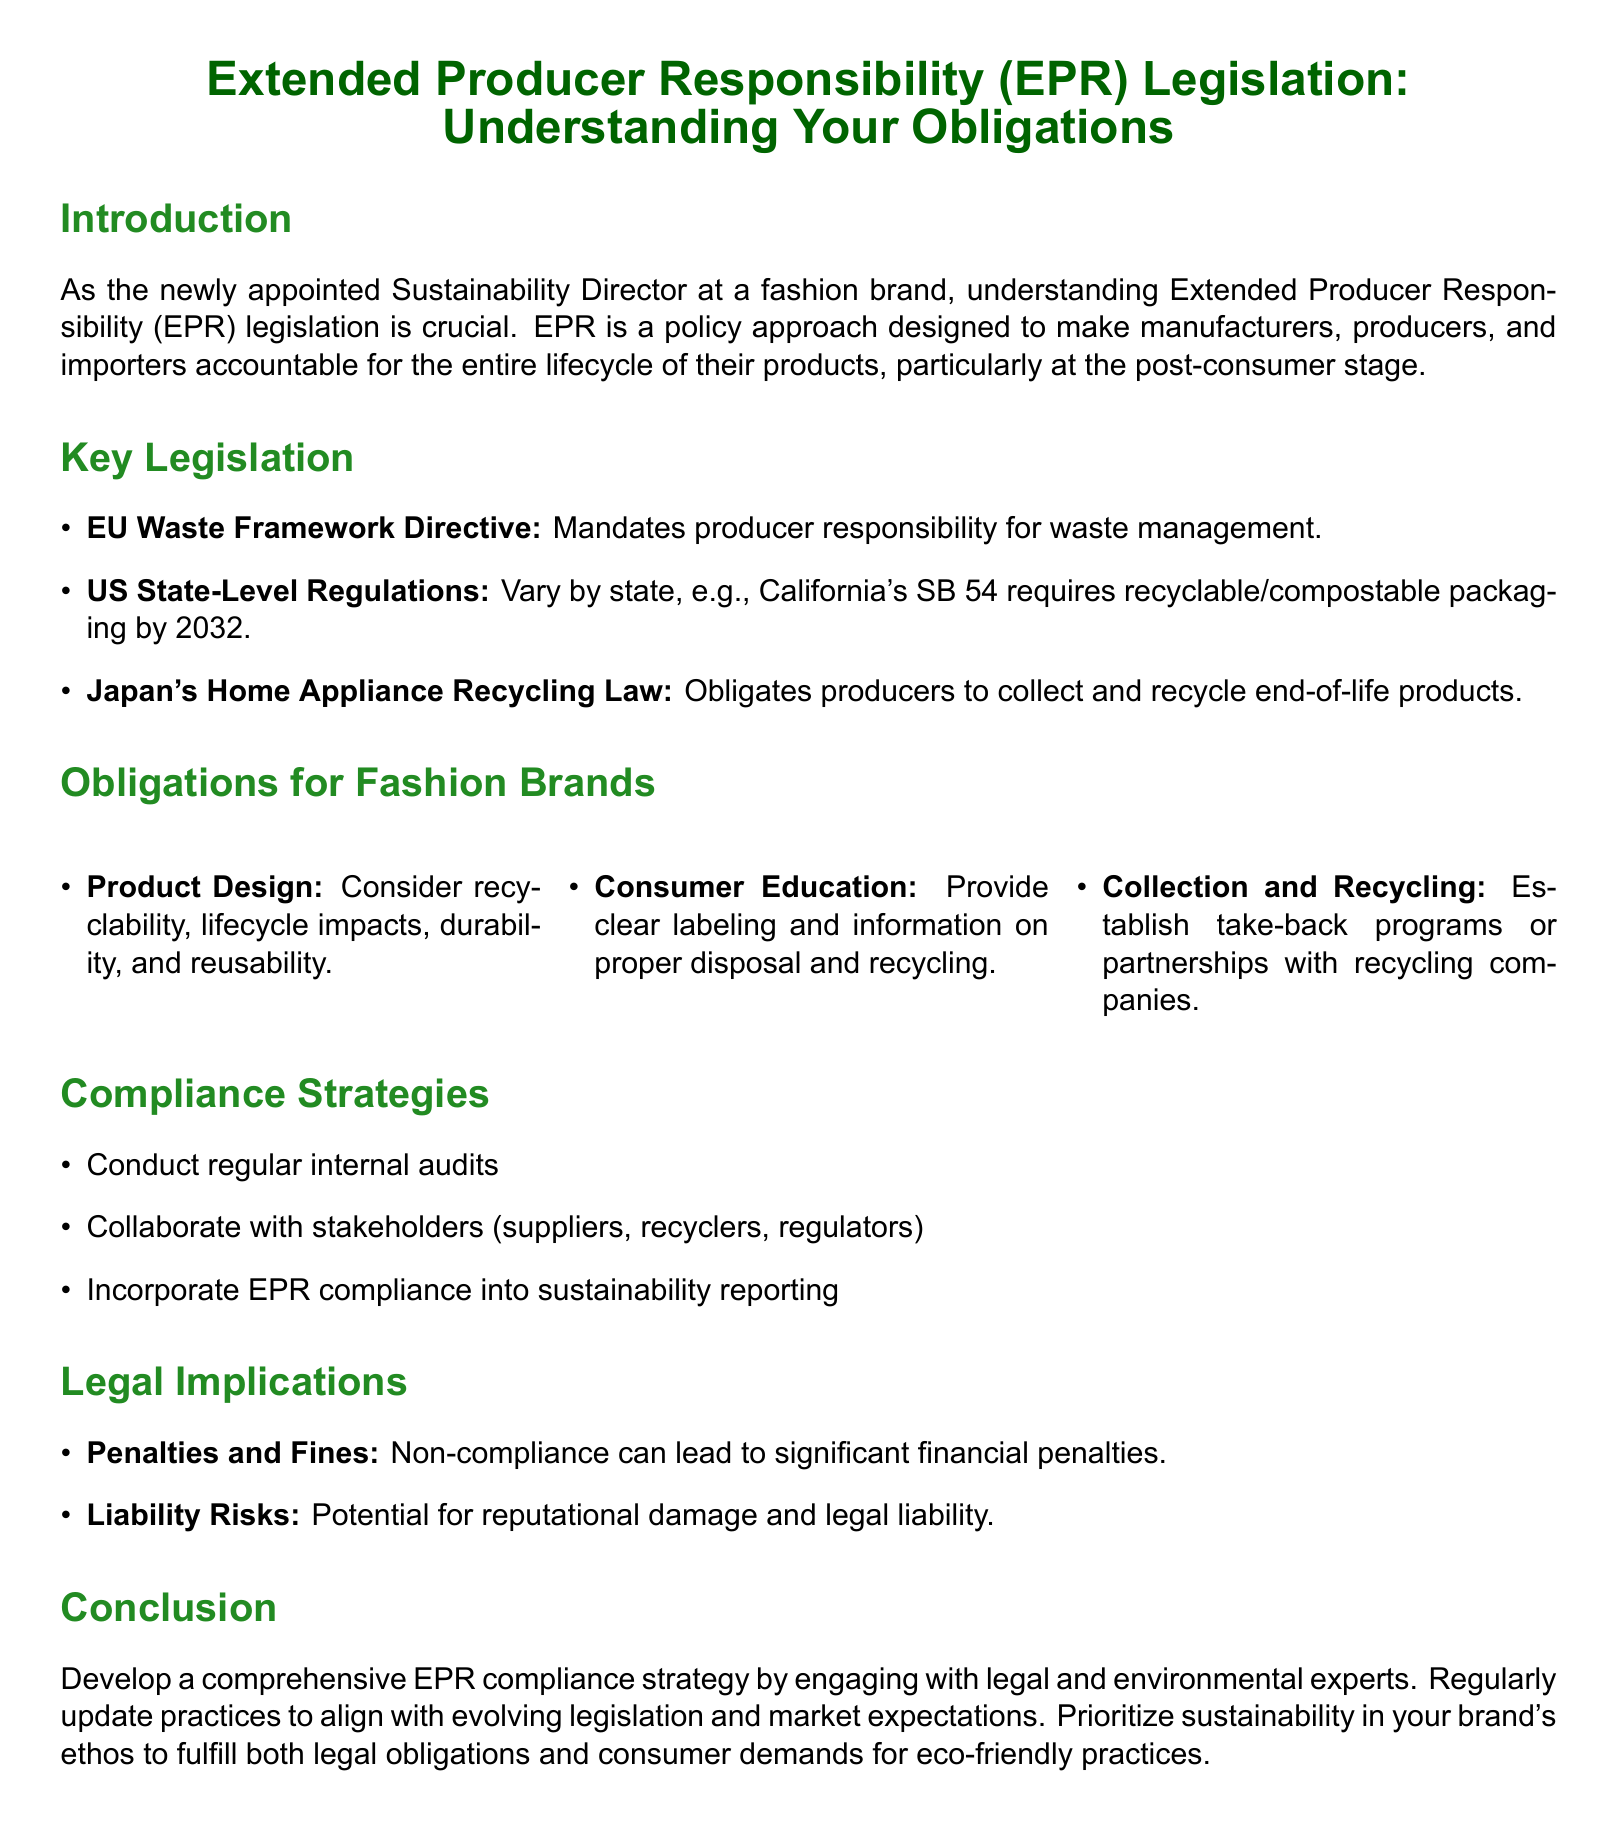What is EPR? EPR stands for Extended Producer Responsibility, a policy approach making manufacturers responsible for the lifecycle of their products.
Answer: Extended Producer Responsibility What is the EU directive related to EPR? The document mentions the EU Waste Framework Directive mandating producer responsibility for waste management.
Answer: EU Waste Framework Directive What must fashion brands consider in product design under EPR? The obligations for fashion brands highlight that they should consider recyclability, lifecycle impacts, durability, and reusability.
Answer: Recyclability, lifecycle impacts, durability, and reusability What is a compliance strategy suggested for fashion brands? The document suggests conducting regular internal audits as one of the compliance strategies for fashion brands.
Answer: Regular internal audits What are the potential risks of non-compliance? The legal implications section mentions penalties and fines as one of the significant risks of non-compliance.
Answer: Penalties and fines How does the document suggest fashion brands engage with EPR? It advises engaging with legal and environmental experts to develop a comprehensive EPR compliance strategy.
Answer: Engaging with legal and environmental experts What is California's EPR requirement? The document states California's SB 54, which requires recyclable/compostable packaging by 2032.
Answer: Recyclable/compostable packaging by 2032 What should brands provide for consumer education? The document notes that clear labeling and information on proper disposal and recycling should be provided for consumer education.
Answer: Clear labeling and information on proper disposal and recycling What can non-compliance lead to? According to the document, non-compliance can lead to significant financial penalties and reputational damage.
Answer: Significant financial penalties and reputational damage 